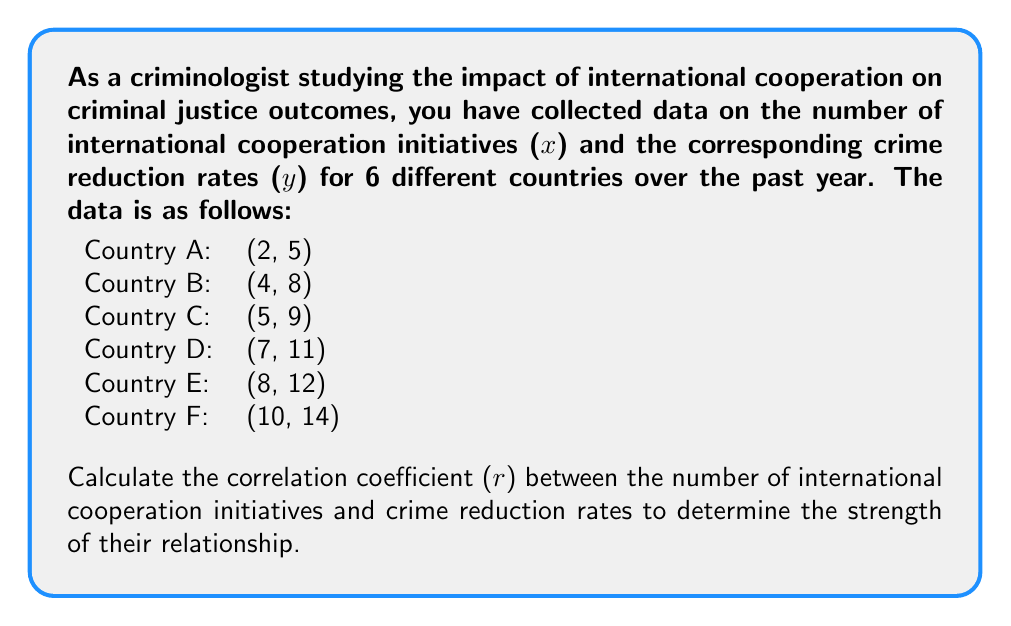Could you help me with this problem? To calculate the correlation coefficient (r), we'll use the formula:

$$ r = \frac{n\sum xy - \sum x \sum y}{\sqrt{[n\sum x^2 - (\sum x)^2][n\sum y^2 - (\sum y)^2]}} $$

Where:
n = number of data points
x = number of international cooperation initiatives
y = crime reduction rates

Step 1: Calculate the necessary sums:
$\sum x = 2 + 4 + 5 + 7 + 8 + 10 = 36$
$\sum y = 5 + 8 + 9 + 11 + 12 + 14 = 59$
$\sum xy = (2)(5) + (4)(8) + (5)(9) + (7)(11) + (8)(12) + (10)(14) = 438$
$\sum x^2 = 2^2 + 4^2 + 5^2 + 7^2 + 8^2 + 10^2 = 262$
$\sum y^2 = 5^2 + 8^2 + 9^2 + 11^2 + 12^2 + 14^2 = 627$

Step 2: Substitute these values into the formula:

$$ r = \frac{6(438) - (36)(59)}{\sqrt{[6(262) - (36)^2][6(627) - (59)^2]}} $$

Step 3: Simplify:

$$ r = \frac{2628 - 2124}{\sqrt{(1572 - 1296)(3762 - 3481)}} $$

$$ r = \frac{504}{\sqrt{(276)(281)}} $$

$$ r = \frac{504}{\sqrt{77556}} $$

$$ r = \frac{504}{278.49} $$

Step 4: Calculate the final result:

$$ r \approx 0.9979 $$
Answer: $r \approx 0.9979$ 